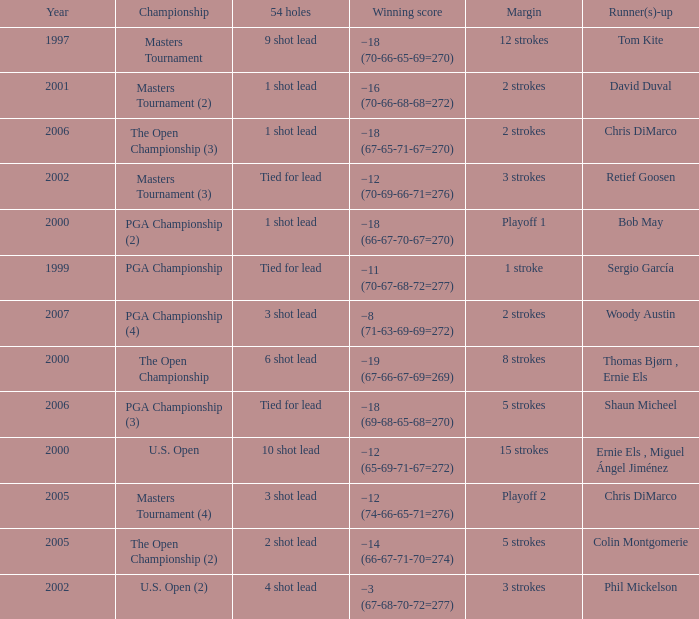 what's the championship where 54 holes is 1 shot lead and runner(s)-up is chris dimarco The Open Championship (3). 